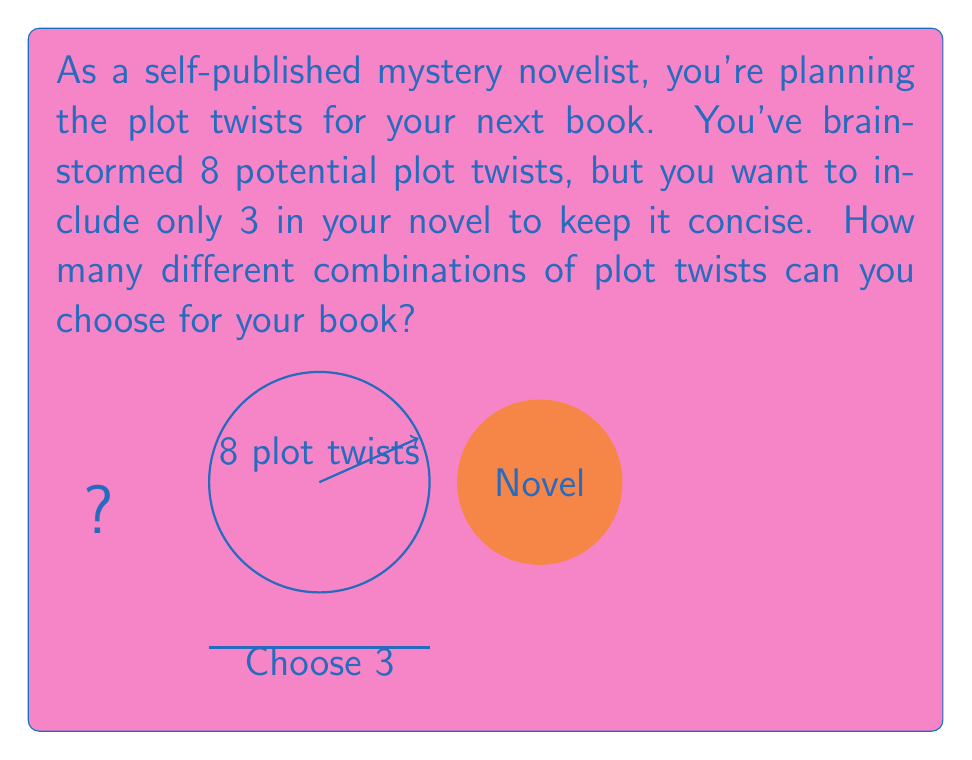Show me your answer to this math problem. To solve this problem, we need to use the combination formula. We are selecting 3 plot twists from a total of 8, where the order doesn't matter (combinations, not permutations).

The formula for combinations is:

$$C(n,r) = \frac{n!}{r!(n-r)!}$$

Where:
$n$ is the total number of items to choose from (8 plot twists)
$r$ is the number of items being chosen (3 plot twists)

Let's substitute our values:

$$C(8,3) = \frac{8!}{3!(8-3)!} = \frac{8!}{3!5!}$$

Now, let's calculate step by step:

1) $8! = 8 \times 7 \times 6 \times 5!$
2) $3! = 3 \times 2 \times 1 = 6$

Substituting:

$$\frac{8 \times 7 \times 6 \times 5!}{6 \times 5!}$$

The $5!$ cancels out in the numerator and denominator:

$$\frac{8 \times 7 \times 6}{6}$$

Multiply the numerator:

$$\frac{336}{6}$$

Divide:

$$56$$

Therefore, there are 56 different combinations of plot twists you can choose for your novel.
Answer: $56$ 